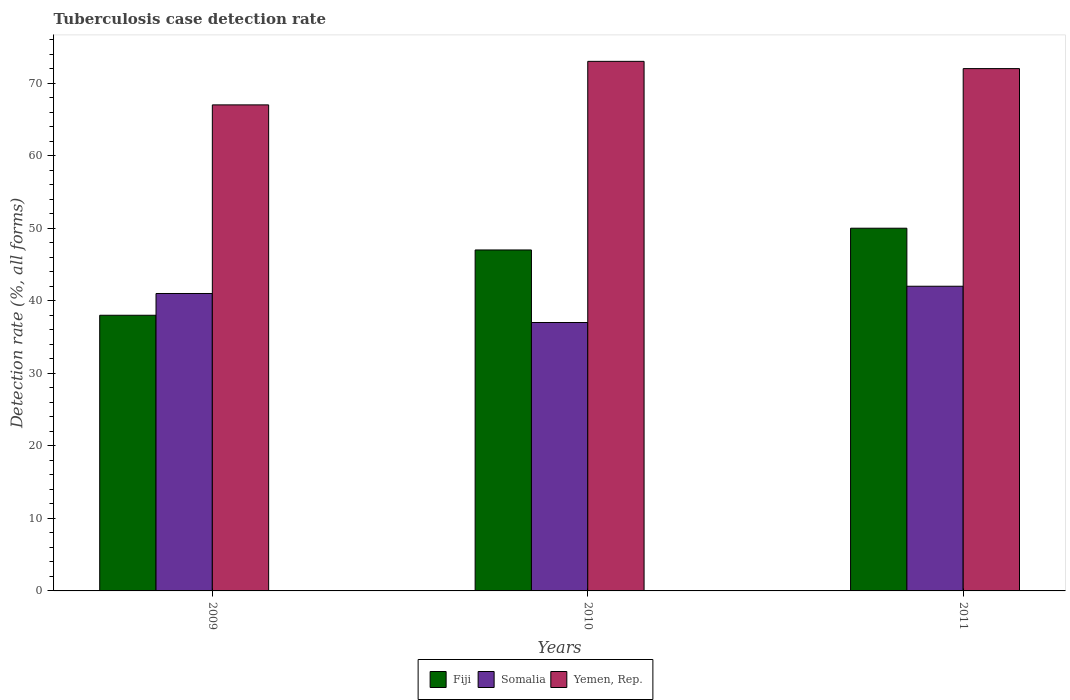How many different coloured bars are there?
Make the answer very short. 3. How many groups of bars are there?
Your answer should be very brief. 3. How many bars are there on the 2nd tick from the right?
Offer a very short reply. 3. What is the tuberculosis case detection rate in in Fiji in 2010?
Your response must be concise. 47. Across all years, what is the maximum tuberculosis case detection rate in in Yemen, Rep.?
Provide a succinct answer. 73. Across all years, what is the minimum tuberculosis case detection rate in in Fiji?
Your answer should be compact. 38. In which year was the tuberculosis case detection rate in in Fiji maximum?
Your answer should be compact. 2011. In which year was the tuberculosis case detection rate in in Somalia minimum?
Your answer should be compact. 2010. What is the total tuberculosis case detection rate in in Somalia in the graph?
Your answer should be compact. 120. What is the difference between the tuberculosis case detection rate in in Fiji in 2009 and that in 2010?
Make the answer very short. -9. What is the average tuberculosis case detection rate in in Somalia per year?
Your response must be concise. 40. In how many years, is the tuberculosis case detection rate in in Somalia greater than 6 %?
Your response must be concise. 3. What is the ratio of the tuberculosis case detection rate in in Somalia in 2009 to that in 2010?
Provide a short and direct response. 1.11. What is the difference between the highest and the lowest tuberculosis case detection rate in in Fiji?
Give a very brief answer. 12. In how many years, is the tuberculosis case detection rate in in Somalia greater than the average tuberculosis case detection rate in in Somalia taken over all years?
Offer a very short reply. 2. What does the 3rd bar from the left in 2009 represents?
Offer a very short reply. Yemen, Rep. What does the 1st bar from the right in 2009 represents?
Keep it short and to the point. Yemen, Rep. How many bars are there?
Give a very brief answer. 9. How many years are there in the graph?
Your answer should be very brief. 3. What is the difference between two consecutive major ticks on the Y-axis?
Provide a short and direct response. 10. Are the values on the major ticks of Y-axis written in scientific E-notation?
Your answer should be very brief. No. Does the graph contain any zero values?
Your response must be concise. No. Does the graph contain grids?
Offer a very short reply. No. Where does the legend appear in the graph?
Your answer should be very brief. Bottom center. How many legend labels are there?
Make the answer very short. 3. How are the legend labels stacked?
Offer a very short reply. Horizontal. What is the title of the graph?
Provide a succinct answer. Tuberculosis case detection rate. What is the label or title of the X-axis?
Your answer should be compact. Years. What is the label or title of the Y-axis?
Offer a very short reply. Detection rate (%, all forms). What is the Detection rate (%, all forms) of Fiji in 2009?
Your answer should be compact. 38. What is the Detection rate (%, all forms) in Fiji in 2010?
Offer a terse response. 47. What is the Detection rate (%, all forms) of Somalia in 2010?
Keep it short and to the point. 37. What is the Detection rate (%, all forms) in Yemen, Rep. in 2010?
Your response must be concise. 73. What is the Detection rate (%, all forms) of Somalia in 2011?
Your response must be concise. 42. What is the Detection rate (%, all forms) of Yemen, Rep. in 2011?
Provide a succinct answer. 72. Across all years, what is the maximum Detection rate (%, all forms) of Fiji?
Give a very brief answer. 50. Across all years, what is the maximum Detection rate (%, all forms) of Somalia?
Offer a terse response. 42. Across all years, what is the minimum Detection rate (%, all forms) in Fiji?
Offer a very short reply. 38. What is the total Detection rate (%, all forms) in Fiji in the graph?
Offer a very short reply. 135. What is the total Detection rate (%, all forms) of Somalia in the graph?
Give a very brief answer. 120. What is the total Detection rate (%, all forms) of Yemen, Rep. in the graph?
Your response must be concise. 212. What is the difference between the Detection rate (%, all forms) of Fiji in 2009 and that in 2010?
Make the answer very short. -9. What is the difference between the Detection rate (%, all forms) of Yemen, Rep. in 2009 and that in 2011?
Ensure brevity in your answer.  -5. What is the difference between the Detection rate (%, all forms) in Somalia in 2010 and that in 2011?
Your answer should be very brief. -5. What is the difference between the Detection rate (%, all forms) of Fiji in 2009 and the Detection rate (%, all forms) of Yemen, Rep. in 2010?
Keep it short and to the point. -35. What is the difference between the Detection rate (%, all forms) in Somalia in 2009 and the Detection rate (%, all forms) in Yemen, Rep. in 2010?
Provide a succinct answer. -32. What is the difference between the Detection rate (%, all forms) of Fiji in 2009 and the Detection rate (%, all forms) of Somalia in 2011?
Your answer should be compact. -4. What is the difference between the Detection rate (%, all forms) in Fiji in 2009 and the Detection rate (%, all forms) in Yemen, Rep. in 2011?
Offer a very short reply. -34. What is the difference between the Detection rate (%, all forms) of Somalia in 2009 and the Detection rate (%, all forms) of Yemen, Rep. in 2011?
Offer a very short reply. -31. What is the difference between the Detection rate (%, all forms) in Somalia in 2010 and the Detection rate (%, all forms) in Yemen, Rep. in 2011?
Keep it short and to the point. -35. What is the average Detection rate (%, all forms) in Fiji per year?
Your answer should be very brief. 45. What is the average Detection rate (%, all forms) of Yemen, Rep. per year?
Give a very brief answer. 70.67. In the year 2009, what is the difference between the Detection rate (%, all forms) in Fiji and Detection rate (%, all forms) in Yemen, Rep.?
Make the answer very short. -29. In the year 2010, what is the difference between the Detection rate (%, all forms) of Fiji and Detection rate (%, all forms) of Yemen, Rep.?
Your answer should be compact. -26. In the year 2010, what is the difference between the Detection rate (%, all forms) of Somalia and Detection rate (%, all forms) of Yemen, Rep.?
Keep it short and to the point. -36. In the year 2011, what is the difference between the Detection rate (%, all forms) in Fiji and Detection rate (%, all forms) in Somalia?
Your response must be concise. 8. In the year 2011, what is the difference between the Detection rate (%, all forms) of Somalia and Detection rate (%, all forms) of Yemen, Rep.?
Your answer should be compact. -30. What is the ratio of the Detection rate (%, all forms) of Fiji in 2009 to that in 2010?
Keep it short and to the point. 0.81. What is the ratio of the Detection rate (%, all forms) in Somalia in 2009 to that in 2010?
Offer a terse response. 1.11. What is the ratio of the Detection rate (%, all forms) in Yemen, Rep. in 2009 to that in 2010?
Offer a terse response. 0.92. What is the ratio of the Detection rate (%, all forms) in Fiji in 2009 to that in 2011?
Offer a very short reply. 0.76. What is the ratio of the Detection rate (%, all forms) in Somalia in 2009 to that in 2011?
Offer a terse response. 0.98. What is the ratio of the Detection rate (%, all forms) of Yemen, Rep. in 2009 to that in 2011?
Offer a terse response. 0.93. What is the ratio of the Detection rate (%, all forms) of Fiji in 2010 to that in 2011?
Your answer should be compact. 0.94. What is the ratio of the Detection rate (%, all forms) of Somalia in 2010 to that in 2011?
Provide a succinct answer. 0.88. What is the ratio of the Detection rate (%, all forms) of Yemen, Rep. in 2010 to that in 2011?
Your answer should be compact. 1.01. What is the difference between the highest and the second highest Detection rate (%, all forms) of Somalia?
Offer a very short reply. 1. What is the difference between the highest and the second highest Detection rate (%, all forms) of Yemen, Rep.?
Make the answer very short. 1. What is the difference between the highest and the lowest Detection rate (%, all forms) in Yemen, Rep.?
Give a very brief answer. 6. 